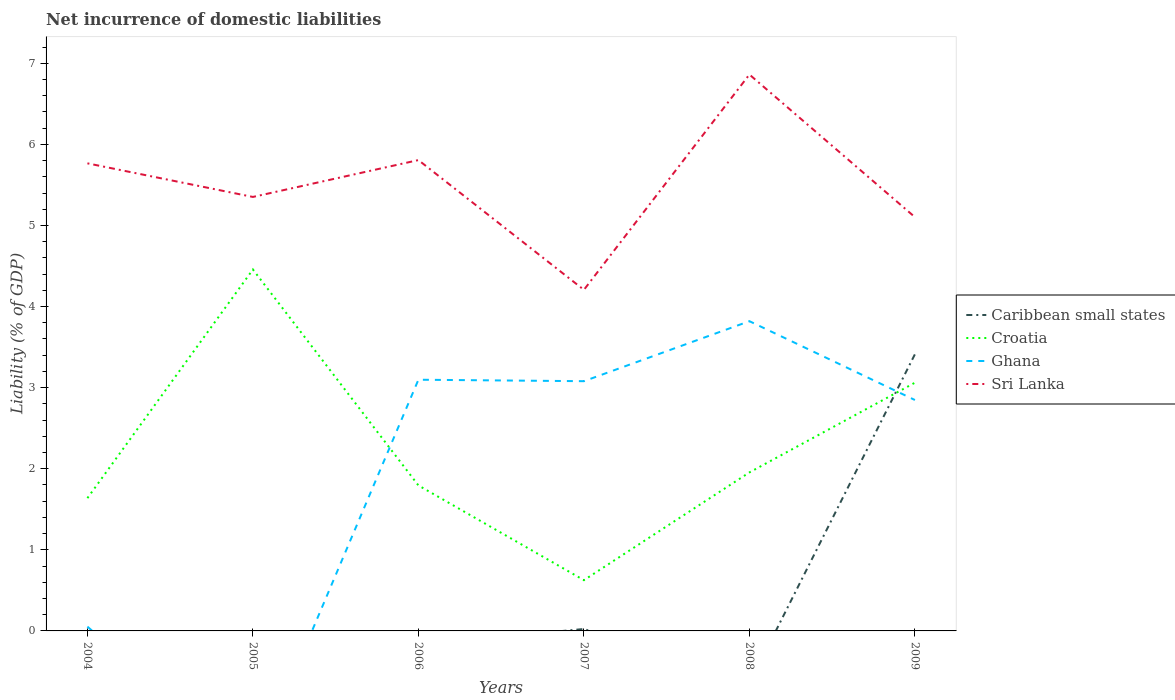Does the line corresponding to Sri Lanka intersect with the line corresponding to Caribbean small states?
Your answer should be very brief. No. Across all years, what is the maximum net incurrence of domestic liabilities in Sri Lanka?
Offer a very short reply. 4.21. What is the total net incurrence of domestic liabilities in Ghana in the graph?
Provide a succinct answer. -3.03. What is the difference between the highest and the second highest net incurrence of domestic liabilities in Ghana?
Offer a terse response. 3.82. Is the net incurrence of domestic liabilities in Sri Lanka strictly greater than the net incurrence of domestic liabilities in Ghana over the years?
Your answer should be compact. No. How many lines are there?
Make the answer very short. 4. How many years are there in the graph?
Give a very brief answer. 6. Are the values on the major ticks of Y-axis written in scientific E-notation?
Keep it short and to the point. No. Does the graph contain any zero values?
Provide a succinct answer. Yes. Where does the legend appear in the graph?
Provide a succinct answer. Center right. How many legend labels are there?
Keep it short and to the point. 4. How are the legend labels stacked?
Give a very brief answer. Vertical. What is the title of the graph?
Your answer should be very brief. Net incurrence of domestic liabilities. Does "Afghanistan" appear as one of the legend labels in the graph?
Give a very brief answer. No. What is the label or title of the Y-axis?
Offer a terse response. Liability (% of GDP). What is the Liability (% of GDP) of Croatia in 2004?
Provide a short and direct response. 1.64. What is the Liability (% of GDP) of Ghana in 2004?
Provide a short and direct response. 0.05. What is the Liability (% of GDP) of Sri Lanka in 2004?
Provide a succinct answer. 5.77. What is the Liability (% of GDP) of Caribbean small states in 2005?
Provide a short and direct response. 0. What is the Liability (% of GDP) of Croatia in 2005?
Provide a succinct answer. 4.46. What is the Liability (% of GDP) of Ghana in 2005?
Make the answer very short. 0. What is the Liability (% of GDP) in Sri Lanka in 2005?
Your answer should be compact. 5.35. What is the Liability (% of GDP) in Croatia in 2006?
Provide a succinct answer. 1.79. What is the Liability (% of GDP) in Ghana in 2006?
Ensure brevity in your answer.  3.1. What is the Liability (% of GDP) in Sri Lanka in 2006?
Offer a terse response. 5.81. What is the Liability (% of GDP) of Caribbean small states in 2007?
Offer a very short reply. 0.02. What is the Liability (% of GDP) of Croatia in 2007?
Make the answer very short. 0.63. What is the Liability (% of GDP) in Ghana in 2007?
Ensure brevity in your answer.  3.08. What is the Liability (% of GDP) in Sri Lanka in 2007?
Your answer should be very brief. 4.21. What is the Liability (% of GDP) of Croatia in 2008?
Ensure brevity in your answer.  1.95. What is the Liability (% of GDP) in Ghana in 2008?
Offer a terse response. 3.82. What is the Liability (% of GDP) in Sri Lanka in 2008?
Keep it short and to the point. 6.86. What is the Liability (% of GDP) of Caribbean small states in 2009?
Make the answer very short. 3.41. What is the Liability (% of GDP) of Croatia in 2009?
Your answer should be very brief. 3.06. What is the Liability (% of GDP) in Ghana in 2009?
Your answer should be very brief. 2.85. What is the Liability (% of GDP) in Sri Lanka in 2009?
Provide a succinct answer. 5.1. Across all years, what is the maximum Liability (% of GDP) in Caribbean small states?
Provide a short and direct response. 3.41. Across all years, what is the maximum Liability (% of GDP) in Croatia?
Give a very brief answer. 4.46. Across all years, what is the maximum Liability (% of GDP) of Ghana?
Your response must be concise. 3.82. Across all years, what is the maximum Liability (% of GDP) of Sri Lanka?
Your response must be concise. 6.86. Across all years, what is the minimum Liability (% of GDP) of Caribbean small states?
Offer a very short reply. 0. Across all years, what is the minimum Liability (% of GDP) in Croatia?
Offer a very short reply. 0.63. Across all years, what is the minimum Liability (% of GDP) in Ghana?
Your response must be concise. 0. Across all years, what is the minimum Liability (% of GDP) of Sri Lanka?
Offer a terse response. 4.21. What is the total Liability (% of GDP) of Caribbean small states in the graph?
Your response must be concise. 3.44. What is the total Liability (% of GDP) in Croatia in the graph?
Make the answer very short. 13.53. What is the total Liability (% of GDP) of Ghana in the graph?
Keep it short and to the point. 12.9. What is the total Liability (% of GDP) in Sri Lanka in the graph?
Keep it short and to the point. 33.09. What is the difference between the Liability (% of GDP) in Croatia in 2004 and that in 2005?
Your answer should be very brief. -2.82. What is the difference between the Liability (% of GDP) in Sri Lanka in 2004 and that in 2005?
Your response must be concise. 0.41. What is the difference between the Liability (% of GDP) in Croatia in 2004 and that in 2006?
Provide a short and direct response. -0.16. What is the difference between the Liability (% of GDP) in Ghana in 2004 and that in 2006?
Keep it short and to the point. -3.04. What is the difference between the Liability (% of GDP) of Sri Lanka in 2004 and that in 2006?
Make the answer very short. -0.04. What is the difference between the Liability (% of GDP) of Croatia in 2004 and that in 2007?
Keep it short and to the point. 1.01. What is the difference between the Liability (% of GDP) of Ghana in 2004 and that in 2007?
Provide a short and direct response. -3.03. What is the difference between the Liability (% of GDP) in Sri Lanka in 2004 and that in 2007?
Your response must be concise. 1.56. What is the difference between the Liability (% of GDP) in Croatia in 2004 and that in 2008?
Offer a very short reply. -0.32. What is the difference between the Liability (% of GDP) in Ghana in 2004 and that in 2008?
Provide a succinct answer. -3.77. What is the difference between the Liability (% of GDP) in Sri Lanka in 2004 and that in 2008?
Give a very brief answer. -1.1. What is the difference between the Liability (% of GDP) in Croatia in 2004 and that in 2009?
Provide a short and direct response. -1.42. What is the difference between the Liability (% of GDP) in Ghana in 2004 and that in 2009?
Your answer should be compact. -2.79. What is the difference between the Liability (% of GDP) in Sri Lanka in 2004 and that in 2009?
Your answer should be very brief. 0.66. What is the difference between the Liability (% of GDP) of Croatia in 2005 and that in 2006?
Keep it short and to the point. 2.66. What is the difference between the Liability (% of GDP) in Sri Lanka in 2005 and that in 2006?
Offer a terse response. -0.45. What is the difference between the Liability (% of GDP) in Croatia in 2005 and that in 2007?
Offer a very short reply. 3.83. What is the difference between the Liability (% of GDP) of Sri Lanka in 2005 and that in 2007?
Keep it short and to the point. 1.15. What is the difference between the Liability (% of GDP) of Croatia in 2005 and that in 2008?
Provide a succinct answer. 2.5. What is the difference between the Liability (% of GDP) of Sri Lanka in 2005 and that in 2008?
Offer a terse response. -1.51. What is the difference between the Liability (% of GDP) in Croatia in 2005 and that in 2009?
Keep it short and to the point. 1.4. What is the difference between the Liability (% of GDP) in Sri Lanka in 2005 and that in 2009?
Your answer should be very brief. 0.25. What is the difference between the Liability (% of GDP) of Croatia in 2006 and that in 2007?
Make the answer very short. 1.17. What is the difference between the Liability (% of GDP) in Ghana in 2006 and that in 2007?
Your answer should be very brief. 0.02. What is the difference between the Liability (% of GDP) of Sri Lanka in 2006 and that in 2007?
Your response must be concise. 1.6. What is the difference between the Liability (% of GDP) in Croatia in 2006 and that in 2008?
Your answer should be very brief. -0.16. What is the difference between the Liability (% of GDP) of Ghana in 2006 and that in 2008?
Your response must be concise. -0.72. What is the difference between the Liability (% of GDP) of Sri Lanka in 2006 and that in 2008?
Provide a short and direct response. -1.06. What is the difference between the Liability (% of GDP) of Croatia in 2006 and that in 2009?
Offer a very short reply. -1.27. What is the difference between the Liability (% of GDP) of Ghana in 2006 and that in 2009?
Provide a short and direct response. 0.25. What is the difference between the Liability (% of GDP) of Sri Lanka in 2006 and that in 2009?
Your answer should be very brief. 0.7. What is the difference between the Liability (% of GDP) in Croatia in 2007 and that in 2008?
Your answer should be compact. -1.33. What is the difference between the Liability (% of GDP) in Ghana in 2007 and that in 2008?
Provide a short and direct response. -0.74. What is the difference between the Liability (% of GDP) of Sri Lanka in 2007 and that in 2008?
Make the answer very short. -2.66. What is the difference between the Liability (% of GDP) in Caribbean small states in 2007 and that in 2009?
Give a very brief answer. -3.39. What is the difference between the Liability (% of GDP) in Croatia in 2007 and that in 2009?
Your response must be concise. -2.44. What is the difference between the Liability (% of GDP) in Ghana in 2007 and that in 2009?
Keep it short and to the point. 0.23. What is the difference between the Liability (% of GDP) of Sri Lanka in 2007 and that in 2009?
Your response must be concise. -0.9. What is the difference between the Liability (% of GDP) in Croatia in 2008 and that in 2009?
Provide a short and direct response. -1.11. What is the difference between the Liability (% of GDP) of Ghana in 2008 and that in 2009?
Provide a short and direct response. 0.97. What is the difference between the Liability (% of GDP) of Sri Lanka in 2008 and that in 2009?
Provide a short and direct response. 1.76. What is the difference between the Liability (% of GDP) in Croatia in 2004 and the Liability (% of GDP) in Sri Lanka in 2005?
Ensure brevity in your answer.  -3.71. What is the difference between the Liability (% of GDP) in Ghana in 2004 and the Liability (% of GDP) in Sri Lanka in 2005?
Offer a terse response. -5.3. What is the difference between the Liability (% of GDP) in Croatia in 2004 and the Liability (% of GDP) in Ghana in 2006?
Ensure brevity in your answer.  -1.46. What is the difference between the Liability (% of GDP) in Croatia in 2004 and the Liability (% of GDP) in Sri Lanka in 2006?
Offer a very short reply. -4.17. What is the difference between the Liability (% of GDP) in Ghana in 2004 and the Liability (% of GDP) in Sri Lanka in 2006?
Provide a short and direct response. -5.75. What is the difference between the Liability (% of GDP) in Croatia in 2004 and the Liability (% of GDP) in Ghana in 2007?
Give a very brief answer. -1.44. What is the difference between the Liability (% of GDP) of Croatia in 2004 and the Liability (% of GDP) of Sri Lanka in 2007?
Provide a short and direct response. -2.57. What is the difference between the Liability (% of GDP) of Ghana in 2004 and the Liability (% of GDP) of Sri Lanka in 2007?
Keep it short and to the point. -4.15. What is the difference between the Liability (% of GDP) of Croatia in 2004 and the Liability (% of GDP) of Ghana in 2008?
Your answer should be very brief. -2.18. What is the difference between the Liability (% of GDP) of Croatia in 2004 and the Liability (% of GDP) of Sri Lanka in 2008?
Provide a short and direct response. -5.22. What is the difference between the Liability (% of GDP) in Ghana in 2004 and the Liability (% of GDP) in Sri Lanka in 2008?
Keep it short and to the point. -6.81. What is the difference between the Liability (% of GDP) of Croatia in 2004 and the Liability (% of GDP) of Ghana in 2009?
Give a very brief answer. -1.21. What is the difference between the Liability (% of GDP) in Croatia in 2004 and the Liability (% of GDP) in Sri Lanka in 2009?
Give a very brief answer. -3.47. What is the difference between the Liability (% of GDP) in Ghana in 2004 and the Liability (% of GDP) in Sri Lanka in 2009?
Ensure brevity in your answer.  -5.05. What is the difference between the Liability (% of GDP) of Croatia in 2005 and the Liability (% of GDP) of Ghana in 2006?
Your response must be concise. 1.36. What is the difference between the Liability (% of GDP) of Croatia in 2005 and the Liability (% of GDP) of Sri Lanka in 2006?
Offer a terse response. -1.35. What is the difference between the Liability (% of GDP) of Croatia in 2005 and the Liability (% of GDP) of Ghana in 2007?
Make the answer very short. 1.38. What is the difference between the Liability (% of GDP) of Croatia in 2005 and the Liability (% of GDP) of Sri Lanka in 2007?
Your answer should be very brief. 0.25. What is the difference between the Liability (% of GDP) in Croatia in 2005 and the Liability (% of GDP) in Ghana in 2008?
Provide a short and direct response. 0.64. What is the difference between the Liability (% of GDP) of Croatia in 2005 and the Liability (% of GDP) of Sri Lanka in 2008?
Provide a succinct answer. -2.4. What is the difference between the Liability (% of GDP) in Croatia in 2005 and the Liability (% of GDP) in Ghana in 2009?
Offer a very short reply. 1.61. What is the difference between the Liability (% of GDP) in Croatia in 2005 and the Liability (% of GDP) in Sri Lanka in 2009?
Make the answer very short. -0.65. What is the difference between the Liability (% of GDP) in Croatia in 2006 and the Liability (% of GDP) in Ghana in 2007?
Give a very brief answer. -1.29. What is the difference between the Liability (% of GDP) in Croatia in 2006 and the Liability (% of GDP) in Sri Lanka in 2007?
Offer a very short reply. -2.41. What is the difference between the Liability (% of GDP) of Ghana in 2006 and the Liability (% of GDP) of Sri Lanka in 2007?
Ensure brevity in your answer.  -1.11. What is the difference between the Liability (% of GDP) of Croatia in 2006 and the Liability (% of GDP) of Ghana in 2008?
Make the answer very short. -2.03. What is the difference between the Liability (% of GDP) of Croatia in 2006 and the Liability (% of GDP) of Sri Lanka in 2008?
Your response must be concise. -5.07. What is the difference between the Liability (% of GDP) in Ghana in 2006 and the Liability (% of GDP) in Sri Lanka in 2008?
Your answer should be compact. -3.76. What is the difference between the Liability (% of GDP) in Croatia in 2006 and the Liability (% of GDP) in Ghana in 2009?
Provide a short and direct response. -1.05. What is the difference between the Liability (% of GDP) in Croatia in 2006 and the Liability (% of GDP) in Sri Lanka in 2009?
Your answer should be very brief. -3.31. What is the difference between the Liability (% of GDP) in Ghana in 2006 and the Liability (% of GDP) in Sri Lanka in 2009?
Ensure brevity in your answer.  -2. What is the difference between the Liability (% of GDP) in Caribbean small states in 2007 and the Liability (% of GDP) in Croatia in 2008?
Keep it short and to the point. -1.93. What is the difference between the Liability (% of GDP) in Caribbean small states in 2007 and the Liability (% of GDP) in Ghana in 2008?
Provide a succinct answer. -3.8. What is the difference between the Liability (% of GDP) of Caribbean small states in 2007 and the Liability (% of GDP) of Sri Lanka in 2008?
Your response must be concise. -6.84. What is the difference between the Liability (% of GDP) in Croatia in 2007 and the Liability (% of GDP) in Ghana in 2008?
Keep it short and to the point. -3.19. What is the difference between the Liability (% of GDP) of Croatia in 2007 and the Liability (% of GDP) of Sri Lanka in 2008?
Your answer should be compact. -6.24. What is the difference between the Liability (% of GDP) of Ghana in 2007 and the Liability (% of GDP) of Sri Lanka in 2008?
Ensure brevity in your answer.  -3.78. What is the difference between the Liability (% of GDP) in Caribbean small states in 2007 and the Liability (% of GDP) in Croatia in 2009?
Ensure brevity in your answer.  -3.04. What is the difference between the Liability (% of GDP) in Caribbean small states in 2007 and the Liability (% of GDP) in Ghana in 2009?
Offer a very short reply. -2.82. What is the difference between the Liability (% of GDP) in Caribbean small states in 2007 and the Liability (% of GDP) in Sri Lanka in 2009?
Your answer should be compact. -5.08. What is the difference between the Liability (% of GDP) in Croatia in 2007 and the Liability (% of GDP) in Ghana in 2009?
Your answer should be very brief. -2.22. What is the difference between the Liability (% of GDP) in Croatia in 2007 and the Liability (% of GDP) in Sri Lanka in 2009?
Make the answer very short. -4.48. What is the difference between the Liability (% of GDP) of Ghana in 2007 and the Liability (% of GDP) of Sri Lanka in 2009?
Make the answer very short. -2.02. What is the difference between the Liability (% of GDP) in Croatia in 2008 and the Liability (% of GDP) in Ghana in 2009?
Provide a succinct answer. -0.89. What is the difference between the Liability (% of GDP) in Croatia in 2008 and the Liability (% of GDP) in Sri Lanka in 2009?
Keep it short and to the point. -3.15. What is the difference between the Liability (% of GDP) of Ghana in 2008 and the Liability (% of GDP) of Sri Lanka in 2009?
Offer a terse response. -1.28. What is the average Liability (% of GDP) in Caribbean small states per year?
Keep it short and to the point. 0.57. What is the average Liability (% of GDP) in Croatia per year?
Your answer should be compact. 2.25. What is the average Liability (% of GDP) in Ghana per year?
Provide a succinct answer. 2.15. What is the average Liability (% of GDP) in Sri Lanka per year?
Your response must be concise. 5.52. In the year 2004, what is the difference between the Liability (% of GDP) in Croatia and Liability (% of GDP) in Ghana?
Your response must be concise. 1.58. In the year 2004, what is the difference between the Liability (% of GDP) of Croatia and Liability (% of GDP) of Sri Lanka?
Offer a terse response. -4.13. In the year 2004, what is the difference between the Liability (% of GDP) of Ghana and Liability (% of GDP) of Sri Lanka?
Offer a terse response. -5.71. In the year 2005, what is the difference between the Liability (% of GDP) in Croatia and Liability (% of GDP) in Sri Lanka?
Give a very brief answer. -0.89. In the year 2006, what is the difference between the Liability (% of GDP) of Croatia and Liability (% of GDP) of Ghana?
Provide a succinct answer. -1.3. In the year 2006, what is the difference between the Liability (% of GDP) in Croatia and Liability (% of GDP) in Sri Lanka?
Your response must be concise. -4.01. In the year 2006, what is the difference between the Liability (% of GDP) in Ghana and Liability (% of GDP) in Sri Lanka?
Provide a short and direct response. -2.71. In the year 2007, what is the difference between the Liability (% of GDP) in Caribbean small states and Liability (% of GDP) in Croatia?
Your response must be concise. -0.6. In the year 2007, what is the difference between the Liability (% of GDP) in Caribbean small states and Liability (% of GDP) in Ghana?
Your answer should be very brief. -3.06. In the year 2007, what is the difference between the Liability (% of GDP) in Caribbean small states and Liability (% of GDP) in Sri Lanka?
Give a very brief answer. -4.18. In the year 2007, what is the difference between the Liability (% of GDP) of Croatia and Liability (% of GDP) of Ghana?
Offer a terse response. -2.45. In the year 2007, what is the difference between the Liability (% of GDP) of Croatia and Liability (% of GDP) of Sri Lanka?
Give a very brief answer. -3.58. In the year 2007, what is the difference between the Liability (% of GDP) in Ghana and Liability (% of GDP) in Sri Lanka?
Make the answer very short. -1.13. In the year 2008, what is the difference between the Liability (% of GDP) in Croatia and Liability (% of GDP) in Ghana?
Provide a succinct answer. -1.86. In the year 2008, what is the difference between the Liability (% of GDP) of Croatia and Liability (% of GDP) of Sri Lanka?
Offer a terse response. -4.91. In the year 2008, what is the difference between the Liability (% of GDP) of Ghana and Liability (% of GDP) of Sri Lanka?
Your answer should be compact. -3.04. In the year 2009, what is the difference between the Liability (% of GDP) in Caribbean small states and Liability (% of GDP) in Croatia?
Ensure brevity in your answer.  0.35. In the year 2009, what is the difference between the Liability (% of GDP) in Caribbean small states and Liability (% of GDP) in Ghana?
Your answer should be compact. 0.56. In the year 2009, what is the difference between the Liability (% of GDP) in Caribbean small states and Liability (% of GDP) in Sri Lanka?
Make the answer very short. -1.69. In the year 2009, what is the difference between the Liability (% of GDP) of Croatia and Liability (% of GDP) of Ghana?
Ensure brevity in your answer.  0.21. In the year 2009, what is the difference between the Liability (% of GDP) in Croatia and Liability (% of GDP) in Sri Lanka?
Offer a very short reply. -2.04. In the year 2009, what is the difference between the Liability (% of GDP) of Ghana and Liability (% of GDP) of Sri Lanka?
Your answer should be compact. -2.26. What is the ratio of the Liability (% of GDP) in Croatia in 2004 to that in 2005?
Provide a succinct answer. 0.37. What is the ratio of the Liability (% of GDP) of Sri Lanka in 2004 to that in 2005?
Offer a terse response. 1.08. What is the ratio of the Liability (% of GDP) of Croatia in 2004 to that in 2006?
Offer a terse response. 0.91. What is the ratio of the Liability (% of GDP) in Ghana in 2004 to that in 2006?
Offer a terse response. 0.02. What is the ratio of the Liability (% of GDP) in Croatia in 2004 to that in 2007?
Offer a very short reply. 2.62. What is the ratio of the Liability (% of GDP) in Ghana in 2004 to that in 2007?
Your answer should be compact. 0.02. What is the ratio of the Liability (% of GDP) in Sri Lanka in 2004 to that in 2007?
Ensure brevity in your answer.  1.37. What is the ratio of the Liability (% of GDP) of Croatia in 2004 to that in 2008?
Give a very brief answer. 0.84. What is the ratio of the Liability (% of GDP) of Ghana in 2004 to that in 2008?
Your answer should be compact. 0.01. What is the ratio of the Liability (% of GDP) of Sri Lanka in 2004 to that in 2008?
Ensure brevity in your answer.  0.84. What is the ratio of the Liability (% of GDP) in Croatia in 2004 to that in 2009?
Keep it short and to the point. 0.53. What is the ratio of the Liability (% of GDP) of Ghana in 2004 to that in 2009?
Offer a terse response. 0.02. What is the ratio of the Liability (% of GDP) in Sri Lanka in 2004 to that in 2009?
Your answer should be compact. 1.13. What is the ratio of the Liability (% of GDP) in Croatia in 2005 to that in 2006?
Your response must be concise. 2.48. What is the ratio of the Liability (% of GDP) in Sri Lanka in 2005 to that in 2006?
Ensure brevity in your answer.  0.92. What is the ratio of the Liability (% of GDP) in Croatia in 2005 to that in 2007?
Keep it short and to the point. 7.12. What is the ratio of the Liability (% of GDP) of Sri Lanka in 2005 to that in 2007?
Provide a short and direct response. 1.27. What is the ratio of the Liability (% of GDP) in Croatia in 2005 to that in 2008?
Your answer should be very brief. 2.28. What is the ratio of the Liability (% of GDP) of Sri Lanka in 2005 to that in 2008?
Keep it short and to the point. 0.78. What is the ratio of the Liability (% of GDP) in Croatia in 2005 to that in 2009?
Provide a short and direct response. 1.46. What is the ratio of the Liability (% of GDP) in Sri Lanka in 2005 to that in 2009?
Provide a succinct answer. 1.05. What is the ratio of the Liability (% of GDP) of Croatia in 2006 to that in 2007?
Your response must be concise. 2.87. What is the ratio of the Liability (% of GDP) in Ghana in 2006 to that in 2007?
Provide a short and direct response. 1.01. What is the ratio of the Liability (% of GDP) in Sri Lanka in 2006 to that in 2007?
Provide a short and direct response. 1.38. What is the ratio of the Liability (% of GDP) in Croatia in 2006 to that in 2008?
Give a very brief answer. 0.92. What is the ratio of the Liability (% of GDP) of Ghana in 2006 to that in 2008?
Your response must be concise. 0.81. What is the ratio of the Liability (% of GDP) in Sri Lanka in 2006 to that in 2008?
Make the answer very short. 0.85. What is the ratio of the Liability (% of GDP) of Croatia in 2006 to that in 2009?
Provide a succinct answer. 0.59. What is the ratio of the Liability (% of GDP) of Ghana in 2006 to that in 2009?
Make the answer very short. 1.09. What is the ratio of the Liability (% of GDP) in Sri Lanka in 2006 to that in 2009?
Provide a succinct answer. 1.14. What is the ratio of the Liability (% of GDP) in Croatia in 2007 to that in 2008?
Offer a very short reply. 0.32. What is the ratio of the Liability (% of GDP) in Ghana in 2007 to that in 2008?
Make the answer very short. 0.81. What is the ratio of the Liability (% of GDP) of Sri Lanka in 2007 to that in 2008?
Your answer should be very brief. 0.61. What is the ratio of the Liability (% of GDP) in Caribbean small states in 2007 to that in 2009?
Your answer should be compact. 0.01. What is the ratio of the Liability (% of GDP) of Croatia in 2007 to that in 2009?
Ensure brevity in your answer.  0.2. What is the ratio of the Liability (% of GDP) in Ghana in 2007 to that in 2009?
Your answer should be compact. 1.08. What is the ratio of the Liability (% of GDP) in Sri Lanka in 2007 to that in 2009?
Keep it short and to the point. 0.82. What is the ratio of the Liability (% of GDP) in Croatia in 2008 to that in 2009?
Your answer should be very brief. 0.64. What is the ratio of the Liability (% of GDP) in Ghana in 2008 to that in 2009?
Offer a very short reply. 1.34. What is the ratio of the Liability (% of GDP) of Sri Lanka in 2008 to that in 2009?
Ensure brevity in your answer.  1.34. What is the difference between the highest and the second highest Liability (% of GDP) in Croatia?
Keep it short and to the point. 1.4. What is the difference between the highest and the second highest Liability (% of GDP) of Ghana?
Keep it short and to the point. 0.72. What is the difference between the highest and the second highest Liability (% of GDP) of Sri Lanka?
Provide a short and direct response. 1.06. What is the difference between the highest and the lowest Liability (% of GDP) of Caribbean small states?
Keep it short and to the point. 3.41. What is the difference between the highest and the lowest Liability (% of GDP) in Croatia?
Ensure brevity in your answer.  3.83. What is the difference between the highest and the lowest Liability (% of GDP) of Ghana?
Provide a short and direct response. 3.82. What is the difference between the highest and the lowest Liability (% of GDP) in Sri Lanka?
Make the answer very short. 2.66. 